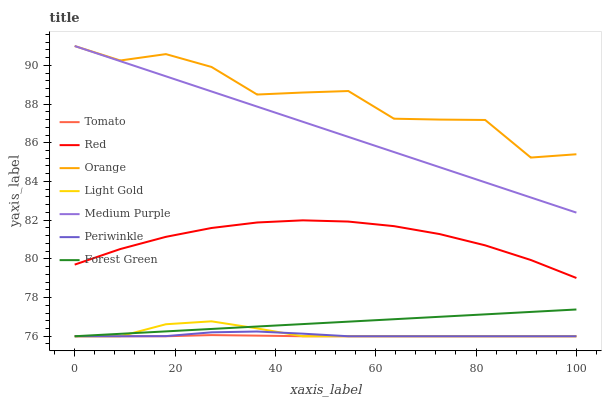Does Tomato have the minimum area under the curve?
Answer yes or no. Yes. Does Orange have the maximum area under the curve?
Answer yes or no. Yes. Does Medium Purple have the minimum area under the curve?
Answer yes or no. No. Does Medium Purple have the maximum area under the curve?
Answer yes or no. No. Is Forest Green the smoothest?
Answer yes or no. Yes. Is Orange the roughest?
Answer yes or no. Yes. Is Medium Purple the smoothest?
Answer yes or no. No. Is Medium Purple the roughest?
Answer yes or no. No. Does Medium Purple have the lowest value?
Answer yes or no. No. Does Forest Green have the highest value?
Answer yes or no. No. Is Periwinkle less than Orange?
Answer yes or no. Yes. Is Orange greater than Red?
Answer yes or no. Yes. Does Periwinkle intersect Orange?
Answer yes or no. No. 